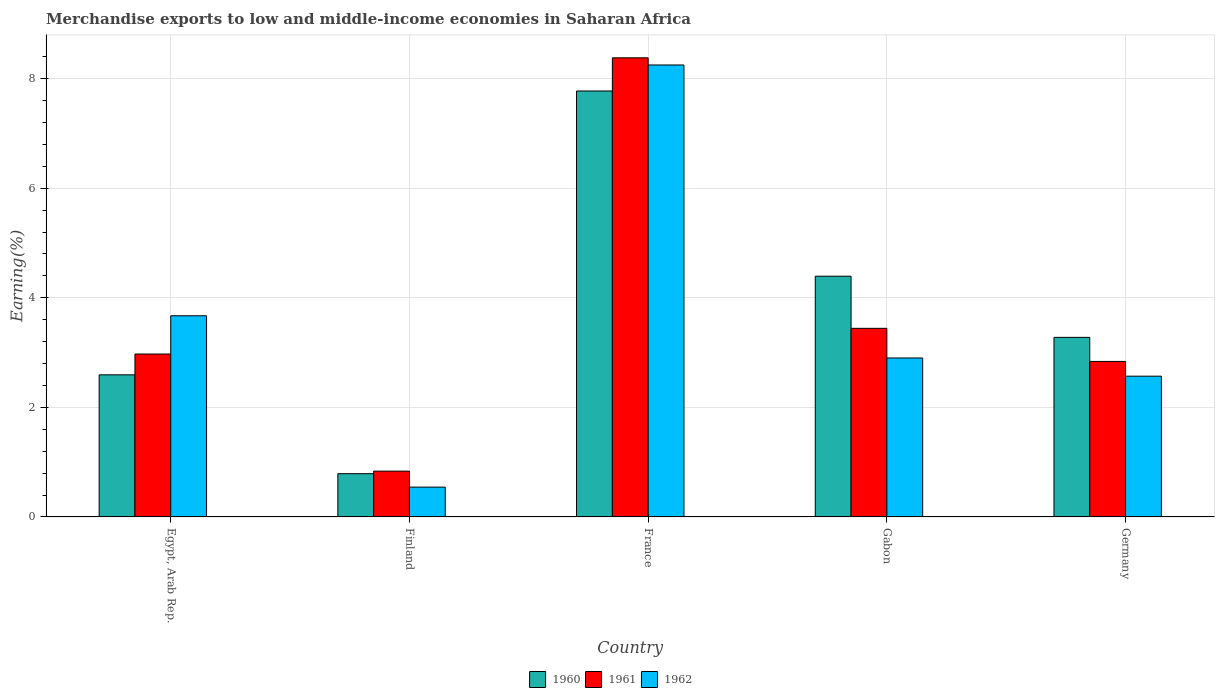How many different coloured bars are there?
Provide a succinct answer. 3. Are the number of bars per tick equal to the number of legend labels?
Ensure brevity in your answer.  Yes. How many bars are there on the 5th tick from the left?
Provide a succinct answer. 3. How many bars are there on the 4th tick from the right?
Your response must be concise. 3. What is the label of the 4th group of bars from the left?
Provide a short and direct response. Gabon. What is the percentage of amount earned from merchandise exports in 1960 in France?
Give a very brief answer. 7.77. Across all countries, what is the maximum percentage of amount earned from merchandise exports in 1961?
Provide a succinct answer. 8.38. Across all countries, what is the minimum percentage of amount earned from merchandise exports in 1961?
Offer a very short reply. 0.84. What is the total percentage of amount earned from merchandise exports in 1962 in the graph?
Your answer should be compact. 17.93. What is the difference between the percentage of amount earned from merchandise exports in 1962 in Gabon and that in Germany?
Provide a short and direct response. 0.33. What is the difference between the percentage of amount earned from merchandise exports in 1960 in France and the percentage of amount earned from merchandise exports in 1961 in Germany?
Keep it short and to the point. 4.94. What is the average percentage of amount earned from merchandise exports in 1960 per country?
Offer a very short reply. 3.77. What is the difference between the percentage of amount earned from merchandise exports of/in 1961 and percentage of amount earned from merchandise exports of/in 1962 in France?
Provide a succinct answer. 0.13. In how many countries, is the percentage of amount earned from merchandise exports in 1962 greater than 4 %?
Make the answer very short. 1. What is the ratio of the percentage of amount earned from merchandise exports in 1961 in Egypt, Arab Rep. to that in Finland?
Offer a very short reply. 3.56. Is the percentage of amount earned from merchandise exports in 1962 in France less than that in Germany?
Provide a succinct answer. No. Is the difference between the percentage of amount earned from merchandise exports in 1961 in Egypt, Arab Rep. and Finland greater than the difference between the percentage of amount earned from merchandise exports in 1962 in Egypt, Arab Rep. and Finland?
Your response must be concise. No. What is the difference between the highest and the second highest percentage of amount earned from merchandise exports in 1960?
Your answer should be very brief. -1.12. What is the difference between the highest and the lowest percentage of amount earned from merchandise exports in 1962?
Your answer should be very brief. 7.7. What does the 2nd bar from the right in Germany represents?
Offer a terse response. 1961. Is it the case that in every country, the sum of the percentage of amount earned from merchandise exports in 1960 and percentage of amount earned from merchandise exports in 1962 is greater than the percentage of amount earned from merchandise exports in 1961?
Offer a very short reply. Yes. What is the difference between two consecutive major ticks on the Y-axis?
Ensure brevity in your answer.  2. Where does the legend appear in the graph?
Your response must be concise. Bottom center. How are the legend labels stacked?
Your answer should be compact. Horizontal. What is the title of the graph?
Keep it short and to the point. Merchandise exports to low and middle-income economies in Saharan Africa. Does "1968" appear as one of the legend labels in the graph?
Your response must be concise. No. What is the label or title of the X-axis?
Offer a very short reply. Country. What is the label or title of the Y-axis?
Ensure brevity in your answer.  Earning(%). What is the Earning(%) of 1960 in Egypt, Arab Rep.?
Your response must be concise. 2.59. What is the Earning(%) of 1961 in Egypt, Arab Rep.?
Your answer should be very brief. 2.97. What is the Earning(%) in 1962 in Egypt, Arab Rep.?
Ensure brevity in your answer.  3.67. What is the Earning(%) in 1960 in Finland?
Provide a short and direct response. 0.79. What is the Earning(%) in 1961 in Finland?
Make the answer very short. 0.84. What is the Earning(%) in 1962 in Finland?
Provide a short and direct response. 0.54. What is the Earning(%) in 1960 in France?
Provide a succinct answer. 7.77. What is the Earning(%) of 1961 in France?
Make the answer very short. 8.38. What is the Earning(%) in 1962 in France?
Your answer should be very brief. 8.25. What is the Earning(%) in 1960 in Gabon?
Give a very brief answer. 4.39. What is the Earning(%) in 1961 in Gabon?
Make the answer very short. 3.44. What is the Earning(%) in 1962 in Gabon?
Provide a short and direct response. 2.9. What is the Earning(%) of 1960 in Germany?
Ensure brevity in your answer.  3.28. What is the Earning(%) in 1961 in Germany?
Offer a terse response. 2.84. What is the Earning(%) of 1962 in Germany?
Offer a very short reply. 2.57. Across all countries, what is the maximum Earning(%) in 1960?
Offer a very short reply. 7.77. Across all countries, what is the maximum Earning(%) of 1961?
Make the answer very short. 8.38. Across all countries, what is the maximum Earning(%) of 1962?
Offer a terse response. 8.25. Across all countries, what is the minimum Earning(%) in 1960?
Provide a succinct answer. 0.79. Across all countries, what is the minimum Earning(%) in 1961?
Your response must be concise. 0.84. Across all countries, what is the minimum Earning(%) of 1962?
Keep it short and to the point. 0.54. What is the total Earning(%) in 1960 in the graph?
Your response must be concise. 18.83. What is the total Earning(%) of 1961 in the graph?
Give a very brief answer. 18.47. What is the total Earning(%) of 1962 in the graph?
Ensure brevity in your answer.  17.93. What is the difference between the Earning(%) of 1960 in Egypt, Arab Rep. and that in Finland?
Make the answer very short. 1.8. What is the difference between the Earning(%) in 1961 in Egypt, Arab Rep. and that in Finland?
Keep it short and to the point. 2.14. What is the difference between the Earning(%) in 1962 in Egypt, Arab Rep. and that in Finland?
Give a very brief answer. 3.13. What is the difference between the Earning(%) of 1960 in Egypt, Arab Rep. and that in France?
Offer a terse response. -5.18. What is the difference between the Earning(%) in 1961 in Egypt, Arab Rep. and that in France?
Provide a succinct answer. -5.41. What is the difference between the Earning(%) in 1962 in Egypt, Arab Rep. and that in France?
Keep it short and to the point. -4.58. What is the difference between the Earning(%) in 1960 in Egypt, Arab Rep. and that in Gabon?
Ensure brevity in your answer.  -1.8. What is the difference between the Earning(%) in 1961 in Egypt, Arab Rep. and that in Gabon?
Give a very brief answer. -0.47. What is the difference between the Earning(%) in 1962 in Egypt, Arab Rep. and that in Gabon?
Your answer should be compact. 0.77. What is the difference between the Earning(%) of 1960 in Egypt, Arab Rep. and that in Germany?
Offer a very short reply. -0.68. What is the difference between the Earning(%) in 1961 in Egypt, Arab Rep. and that in Germany?
Offer a terse response. 0.14. What is the difference between the Earning(%) of 1962 in Egypt, Arab Rep. and that in Germany?
Offer a very short reply. 1.1. What is the difference between the Earning(%) in 1960 in Finland and that in France?
Give a very brief answer. -6.98. What is the difference between the Earning(%) in 1961 in Finland and that in France?
Your answer should be compact. -7.54. What is the difference between the Earning(%) in 1962 in Finland and that in France?
Offer a very short reply. -7.7. What is the difference between the Earning(%) in 1960 in Finland and that in Gabon?
Keep it short and to the point. -3.6. What is the difference between the Earning(%) in 1961 in Finland and that in Gabon?
Provide a succinct answer. -2.61. What is the difference between the Earning(%) in 1962 in Finland and that in Gabon?
Ensure brevity in your answer.  -2.36. What is the difference between the Earning(%) in 1960 in Finland and that in Germany?
Your answer should be very brief. -2.49. What is the difference between the Earning(%) in 1961 in Finland and that in Germany?
Your response must be concise. -2. What is the difference between the Earning(%) in 1962 in Finland and that in Germany?
Offer a very short reply. -2.02. What is the difference between the Earning(%) in 1960 in France and that in Gabon?
Offer a terse response. 3.38. What is the difference between the Earning(%) in 1961 in France and that in Gabon?
Your answer should be very brief. 4.94. What is the difference between the Earning(%) of 1962 in France and that in Gabon?
Your response must be concise. 5.35. What is the difference between the Earning(%) of 1960 in France and that in Germany?
Your answer should be very brief. 4.5. What is the difference between the Earning(%) of 1961 in France and that in Germany?
Give a very brief answer. 5.54. What is the difference between the Earning(%) of 1962 in France and that in Germany?
Offer a very short reply. 5.68. What is the difference between the Earning(%) in 1960 in Gabon and that in Germany?
Ensure brevity in your answer.  1.12. What is the difference between the Earning(%) in 1961 in Gabon and that in Germany?
Offer a terse response. 0.6. What is the difference between the Earning(%) in 1962 in Gabon and that in Germany?
Ensure brevity in your answer.  0.33. What is the difference between the Earning(%) in 1960 in Egypt, Arab Rep. and the Earning(%) in 1961 in Finland?
Offer a terse response. 1.76. What is the difference between the Earning(%) in 1960 in Egypt, Arab Rep. and the Earning(%) in 1962 in Finland?
Provide a short and direct response. 2.05. What is the difference between the Earning(%) of 1961 in Egypt, Arab Rep. and the Earning(%) of 1962 in Finland?
Give a very brief answer. 2.43. What is the difference between the Earning(%) in 1960 in Egypt, Arab Rep. and the Earning(%) in 1961 in France?
Provide a succinct answer. -5.79. What is the difference between the Earning(%) in 1960 in Egypt, Arab Rep. and the Earning(%) in 1962 in France?
Offer a very short reply. -5.66. What is the difference between the Earning(%) of 1961 in Egypt, Arab Rep. and the Earning(%) of 1962 in France?
Make the answer very short. -5.28. What is the difference between the Earning(%) of 1960 in Egypt, Arab Rep. and the Earning(%) of 1961 in Gabon?
Make the answer very short. -0.85. What is the difference between the Earning(%) of 1960 in Egypt, Arab Rep. and the Earning(%) of 1962 in Gabon?
Make the answer very short. -0.31. What is the difference between the Earning(%) in 1961 in Egypt, Arab Rep. and the Earning(%) in 1962 in Gabon?
Your answer should be very brief. 0.07. What is the difference between the Earning(%) of 1960 in Egypt, Arab Rep. and the Earning(%) of 1961 in Germany?
Offer a very short reply. -0.24. What is the difference between the Earning(%) in 1960 in Egypt, Arab Rep. and the Earning(%) in 1962 in Germany?
Provide a succinct answer. 0.02. What is the difference between the Earning(%) of 1961 in Egypt, Arab Rep. and the Earning(%) of 1962 in Germany?
Keep it short and to the point. 0.4. What is the difference between the Earning(%) in 1960 in Finland and the Earning(%) in 1961 in France?
Provide a succinct answer. -7.59. What is the difference between the Earning(%) in 1960 in Finland and the Earning(%) in 1962 in France?
Offer a very short reply. -7.46. What is the difference between the Earning(%) in 1961 in Finland and the Earning(%) in 1962 in France?
Offer a terse response. -7.41. What is the difference between the Earning(%) in 1960 in Finland and the Earning(%) in 1961 in Gabon?
Ensure brevity in your answer.  -2.65. What is the difference between the Earning(%) of 1960 in Finland and the Earning(%) of 1962 in Gabon?
Give a very brief answer. -2.11. What is the difference between the Earning(%) of 1961 in Finland and the Earning(%) of 1962 in Gabon?
Your answer should be compact. -2.07. What is the difference between the Earning(%) in 1960 in Finland and the Earning(%) in 1961 in Germany?
Give a very brief answer. -2.05. What is the difference between the Earning(%) in 1960 in Finland and the Earning(%) in 1962 in Germany?
Keep it short and to the point. -1.78. What is the difference between the Earning(%) in 1961 in Finland and the Earning(%) in 1962 in Germany?
Offer a very short reply. -1.73. What is the difference between the Earning(%) of 1960 in France and the Earning(%) of 1961 in Gabon?
Ensure brevity in your answer.  4.33. What is the difference between the Earning(%) of 1960 in France and the Earning(%) of 1962 in Gabon?
Give a very brief answer. 4.87. What is the difference between the Earning(%) in 1961 in France and the Earning(%) in 1962 in Gabon?
Your response must be concise. 5.48. What is the difference between the Earning(%) in 1960 in France and the Earning(%) in 1961 in Germany?
Your response must be concise. 4.94. What is the difference between the Earning(%) of 1960 in France and the Earning(%) of 1962 in Germany?
Keep it short and to the point. 5.21. What is the difference between the Earning(%) in 1961 in France and the Earning(%) in 1962 in Germany?
Your answer should be very brief. 5.81. What is the difference between the Earning(%) of 1960 in Gabon and the Earning(%) of 1961 in Germany?
Provide a short and direct response. 1.56. What is the difference between the Earning(%) in 1960 in Gabon and the Earning(%) in 1962 in Germany?
Ensure brevity in your answer.  1.82. What is the difference between the Earning(%) of 1961 in Gabon and the Earning(%) of 1962 in Germany?
Your answer should be very brief. 0.87. What is the average Earning(%) in 1960 per country?
Your answer should be compact. 3.77. What is the average Earning(%) in 1961 per country?
Your answer should be very brief. 3.69. What is the average Earning(%) of 1962 per country?
Your response must be concise. 3.59. What is the difference between the Earning(%) in 1960 and Earning(%) in 1961 in Egypt, Arab Rep.?
Keep it short and to the point. -0.38. What is the difference between the Earning(%) of 1960 and Earning(%) of 1962 in Egypt, Arab Rep.?
Provide a short and direct response. -1.08. What is the difference between the Earning(%) in 1961 and Earning(%) in 1962 in Egypt, Arab Rep.?
Your answer should be compact. -0.7. What is the difference between the Earning(%) of 1960 and Earning(%) of 1961 in Finland?
Give a very brief answer. -0.05. What is the difference between the Earning(%) in 1960 and Earning(%) in 1962 in Finland?
Make the answer very short. 0.25. What is the difference between the Earning(%) in 1961 and Earning(%) in 1962 in Finland?
Provide a succinct answer. 0.29. What is the difference between the Earning(%) in 1960 and Earning(%) in 1961 in France?
Provide a short and direct response. -0.61. What is the difference between the Earning(%) of 1960 and Earning(%) of 1962 in France?
Offer a very short reply. -0.47. What is the difference between the Earning(%) in 1961 and Earning(%) in 1962 in France?
Offer a very short reply. 0.13. What is the difference between the Earning(%) of 1960 and Earning(%) of 1961 in Gabon?
Your answer should be very brief. 0.95. What is the difference between the Earning(%) of 1960 and Earning(%) of 1962 in Gabon?
Ensure brevity in your answer.  1.49. What is the difference between the Earning(%) of 1961 and Earning(%) of 1962 in Gabon?
Keep it short and to the point. 0.54. What is the difference between the Earning(%) of 1960 and Earning(%) of 1961 in Germany?
Provide a succinct answer. 0.44. What is the difference between the Earning(%) in 1960 and Earning(%) in 1962 in Germany?
Your answer should be very brief. 0.71. What is the difference between the Earning(%) of 1961 and Earning(%) of 1962 in Germany?
Keep it short and to the point. 0.27. What is the ratio of the Earning(%) in 1960 in Egypt, Arab Rep. to that in Finland?
Your response must be concise. 3.29. What is the ratio of the Earning(%) in 1961 in Egypt, Arab Rep. to that in Finland?
Your response must be concise. 3.56. What is the ratio of the Earning(%) in 1962 in Egypt, Arab Rep. to that in Finland?
Provide a short and direct response. 6.75. What is the ratio of the Earning(%) in 1960 in Egypt, Arab Rep. to that in France?
Make the answer very short. 0.33. What is the ratio of the Earning(%) in 1961 in Egypt, Arab Rep. to that in France?
Offer a very short reply. 0.35. What is the ratio of the Earning(%) in 1962 in Egypt, Arab Rep. to that in France?
Your answer should be very brief. 0.45. What is the ratio of the Earning(%) of 1960 in Egypt, Arab Rep. to that in Gabon?
Keep it short and to the point. 0.59. What is the ratio of the Earning(%) in 1961 in Egypt, Arab Rep. to that in Gabon?
Provide a succinct answer. 0.86. What is the ratio of the Earning(%) in 1962 in Egypt, Arab Rep. to that in Gabon?
Give a very brief answer. 1.27. What is the ratio of the Earning(%) in 1960 in Egypt, Arab Rep. to that in Germany?
Provide a succinct answer. 0.79. What is the ratio of the Earning(%) of 1961 in Egypt, Arab Rep. to that in Germany?
Your answer should be compact. 1.05. What is the ratio of the Earning(%) of 1962 in Egypt, Arab Rep. to that in Germany?
Provide a short and direct response. 1.43. What is the ratio of the Earning(%) in 1960 in Finland to that in France?
Offer a terse response. 0.1. What is the ratio of the Earning(%) of 1961 in Finland to that in France?
Offer a very short reply. 0.1. What is the ratio of the Earning(%) of 1962 in Finland to that in France?
Provide a short and direct response. 0.07. What is the ratio of the Earning(%) in 1960 in Finland to that in Gabon?
Provide a short and direct response. 0.18. What is the ratio of the Earning(%) of 1961 in Finland to that in Gabon?
Your response must be concise. 0.24. What is the ratio of the Earning(%) of 1962 in Finland to that in Gabon?
Your answer should be compact. 0.19. What is the ratio of the Earning(%) of 1960 in Finland to that in Germany?
Offer a very short reply. 0.24. What is the ratio of the Earning(%) of 1961 in Finland to that in Germany?
Offer a terse response. 0.29. What is the ratio of the Earning(%) of 1962 in Finland to that in Germany?
Your answer should be compact. 0.21. What is the ratio of the Earning(%) of 1960 in France to that in Gabon?
Ensure brevity in your answer.  1.77. What is the ratio of the Earning(%) of 1961 in France to that in Gabon?
Your answer should be compact. 2.43. What is the ratio of the Earning(%) in 1962 in France to that in Gabon?
Offer a very short reply. 2.84. What is the ratio of the Earning(%) in 1960 in France to that in Germany?
Make the answer very short. 2.37. What is the ratio of the Earning(%) in 1961 in France to that in Germany?
Provide a short and direct response. 2.95. What is the ratio of the Earning(%) in 1962 in France to that in Germany?
Offer a terse response. 3.21. What is the ratio of the Earning(%) in 1960 in Gabon to that in Germany?
Provide a succinct answer. 1.34. What is the ratio of the Earning(%) in 1961 in Gabon to that in Germany?
Provide a short and direct response. 1.21. What is the ratio of the Earning(%) of 1962 in Gabon to that in Germany?
Offer a very short reply. 1.13. What is the difference between the highest and the second highest Earning(%) of 1960?
Offer a very short reply. 3.38. What is the difference between the highest and the second highest Earning(%) of 1961?
Provide a succinct answer. 4.94. What is the difference between the highest and the second highest Earning(%) in 1962?
Make the answer very short. 4.58. What is the difference between the highest and the lowest Earning(%) in 1960?
Your answer should be compact. 6.98. What is the difference between the highest and the lowest Earning(%) in 1961?
Offer a very short reply. 7.54. What is the difference between the highest and the lowest Earning(%) of 1962?
Provide a succinct answer. 7.7. 